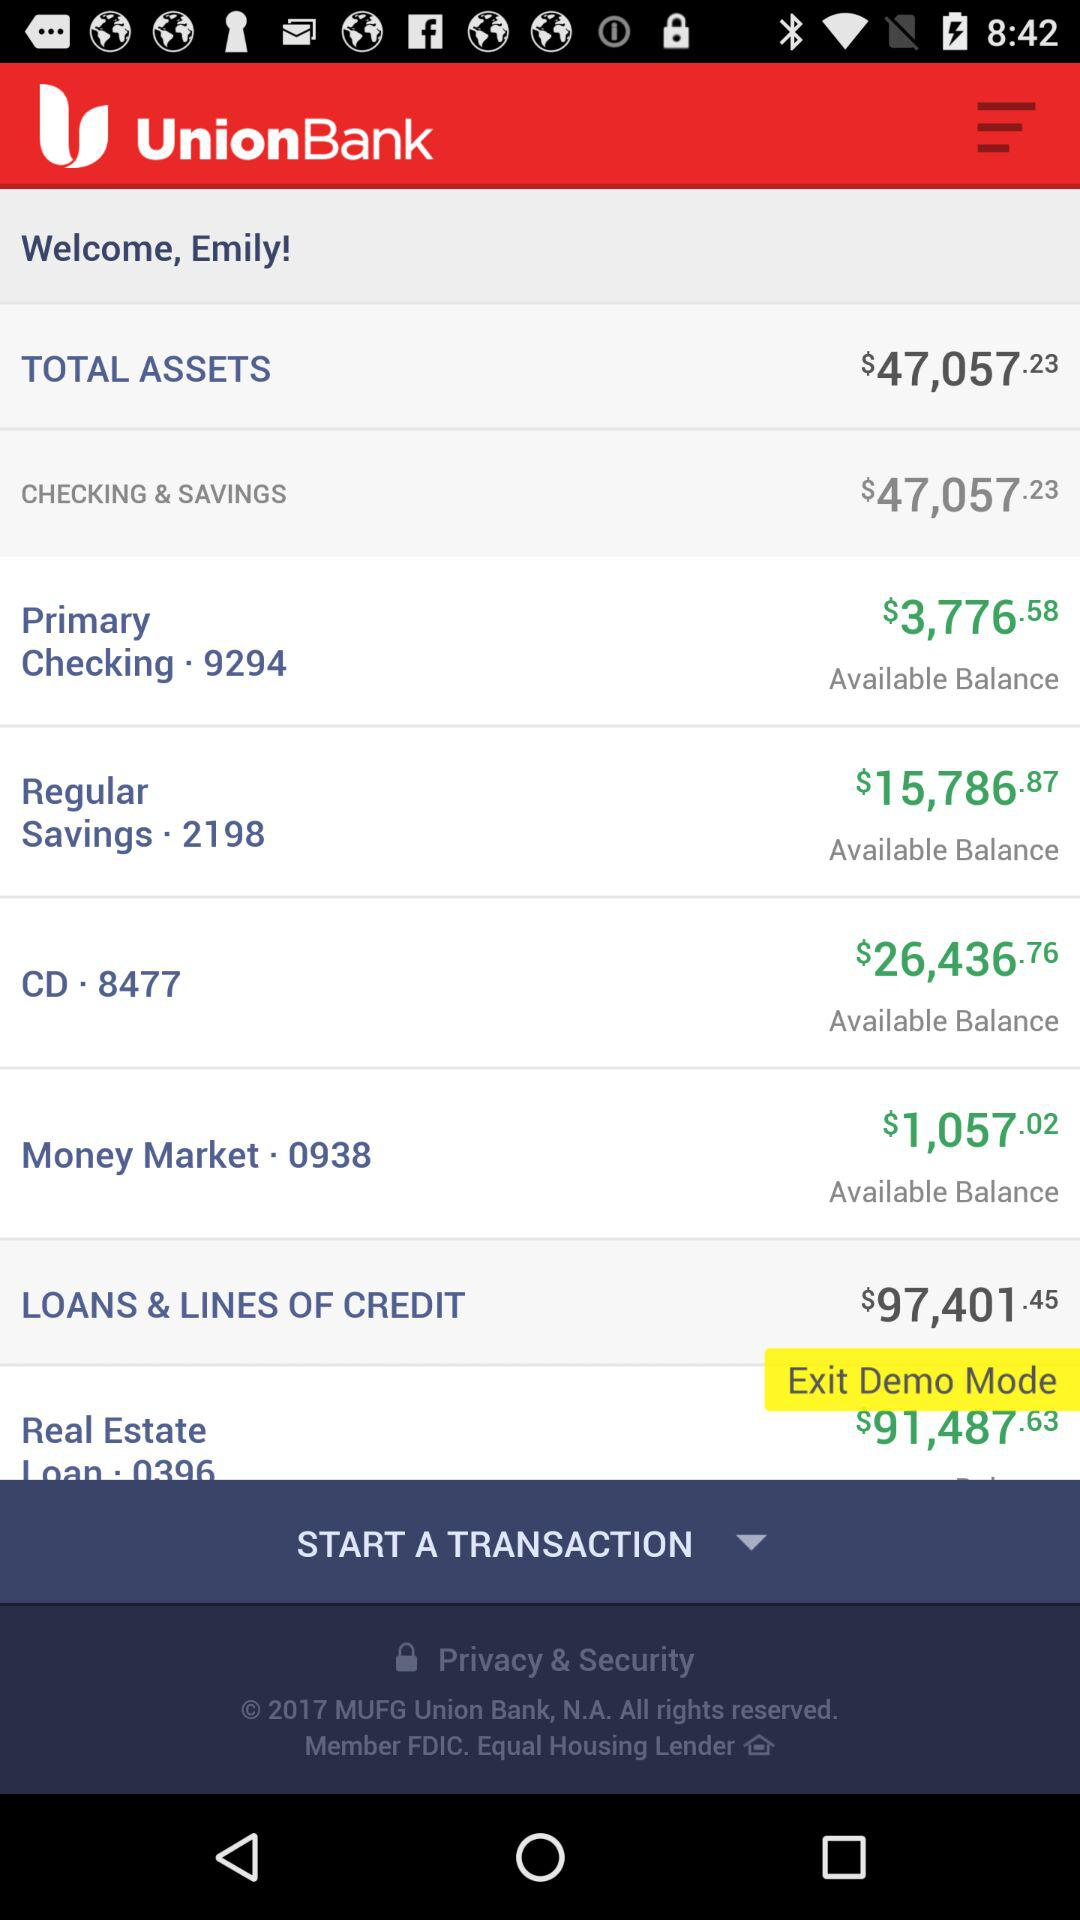What is the amount of money available in the Money Market. 0938 account?
Answer the question using a single word or phrase. $1,057.02 